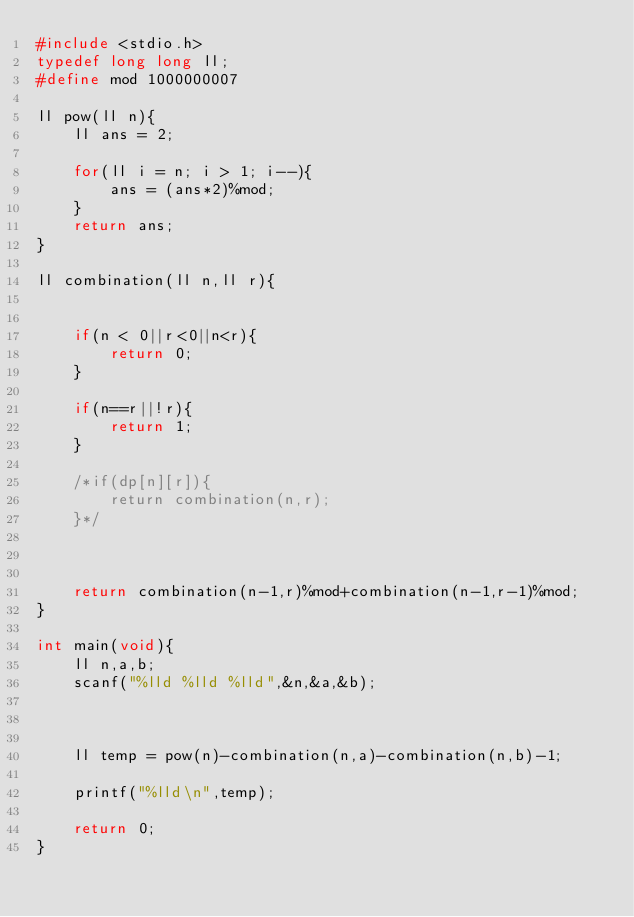Convert code to text. <code><loc_0><loc_0><loc_500><loc_500><_C_>#include <stdio.h>
typedef long long ll;
#define mod 1000000007

ll pow(ll n){
    ll ans = 2;

    for(ll i = n; i > 1; i--){
        ans = (ans*2)%mod;
    }
    return ans;
}

ll combination(ll n,ll r){
    

    if(n < 0||r<0||n<r){
        return 0;
    }

    if(n==r||!r){
        return 1;
    }

    /*if(dp[n][r]){
        return combination(n,r);
    }*/

    
    
    return combination(n-1,r)%mod+combination(n-1,r-1)%mod;
}

int main(void){
    ll n,a,b;
    scanf("%lld %lld %lld",&n,&a,&b);

    

    ll temp = pow(n)-combination(n,a)-combination(n,b)-1;

    printf("%lld\n",temp);

    return 0;
}</code> 